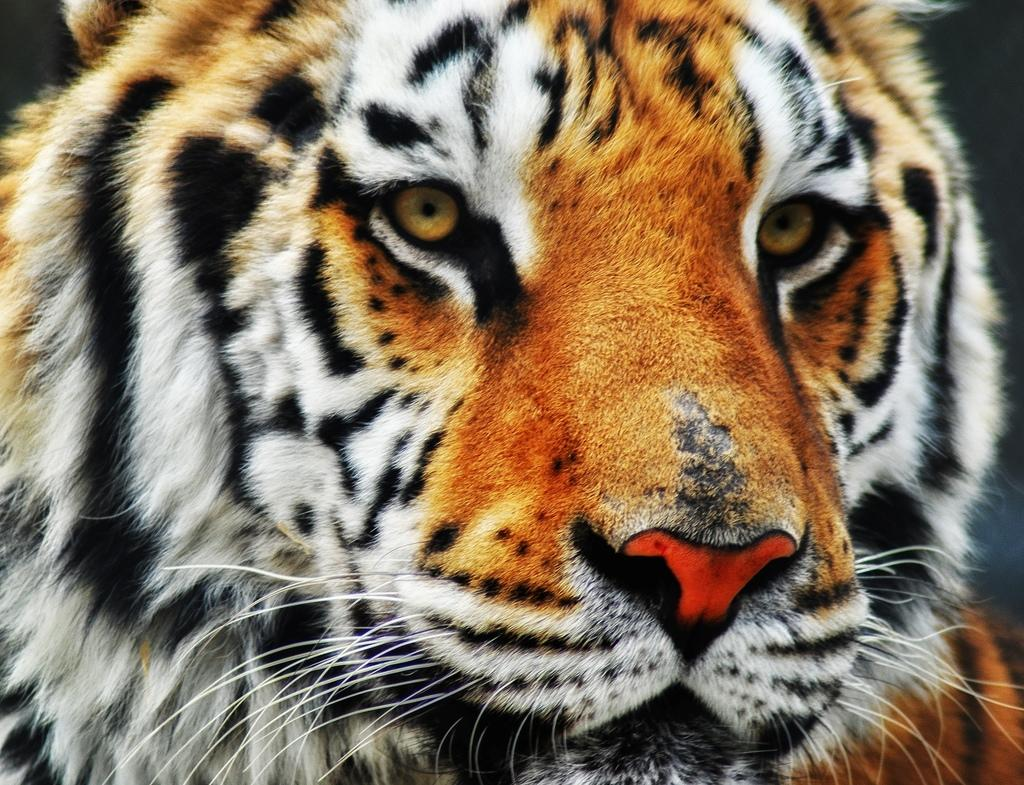What is the color of the background in the image? The background of the image is dark. What animal is located in the middle of the image? There is a tiger in the middle of the image. What type of paper can be seen in the image? There is no paper present in the image; it features a tiger in a dark background. What role does the mother play in the image? There is no mention of a mother or any human presence in the image, as it only features a tiger. 